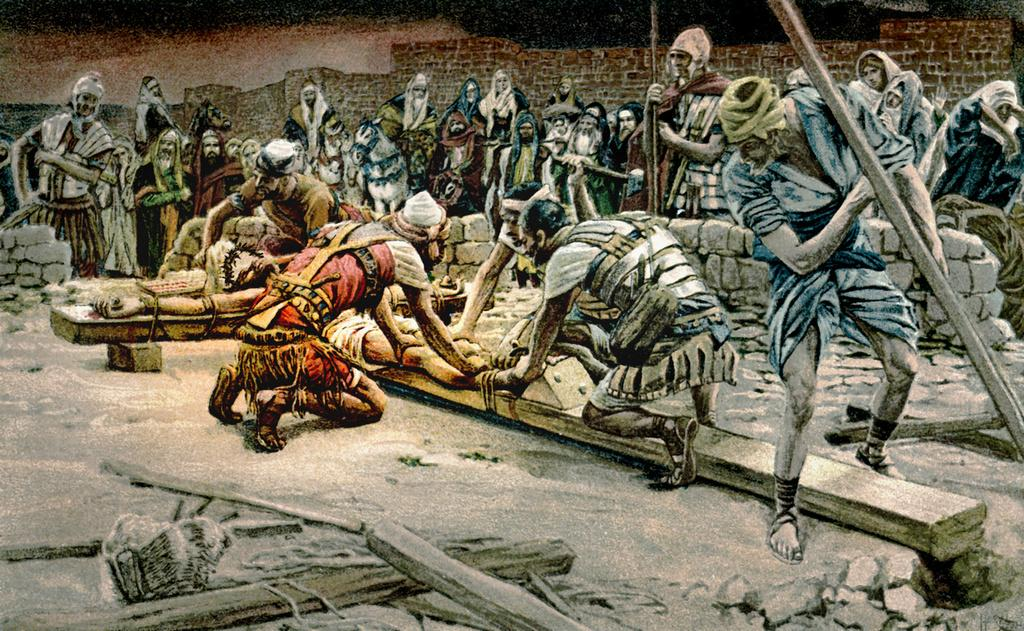What type of image is depicted? The image appears to be an ancient picture. Can you describe the subjects in the image? There are people in the image. What can be seen in the background of the image? There is a wall in the background of the image. What type of toy can be seen being smashed by the people in the image? There is no toy present in the image, nor is there any indication of people smashing anything. 